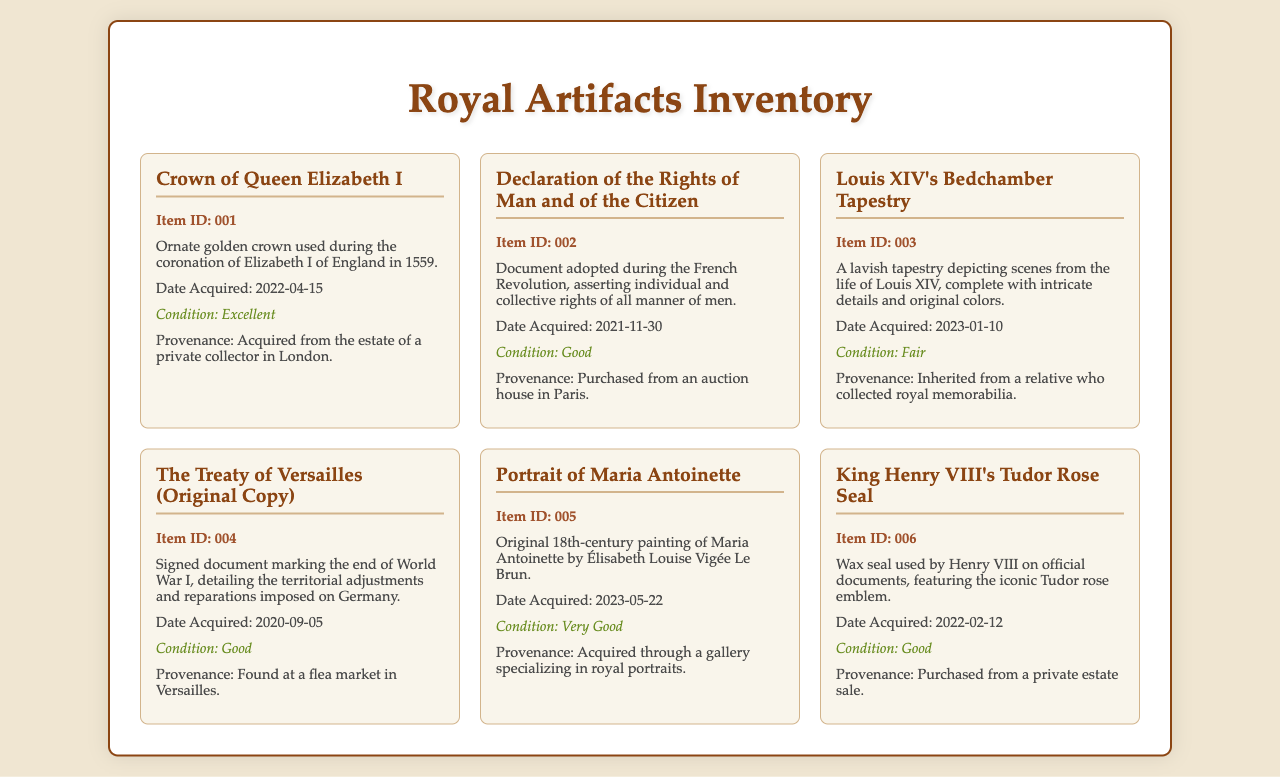What is the item ID of the Crown of Queen Elizabeth I? The item ID is specified next to the artifact title in the document.
Answer: 001 What is the condition of Louis XIV's Bedchamber Tapestry? The condition is mentioned below the description of the artifact.
Answer: Fair Who is the artist of the Portrait of Maria Antoinette? The artist's name is included in the description of the painting.
Answer: Élisabeth Louise Vigée Le Brun When was the Declaration of the Rights of Man and of the Citizen acquired? The acquisition date is listed under each artifact's description.
Answer: 2021-11-30 From where was the Crown of Queen Elizabeth I acquired? The provenance details are provided under the condition of each artifact.
Answer: From the estate of a private collector in London How many artifacts are listed in the inventory? The total number of artifacts can be counted by listing each item in the document.
Answer: 6 What type of document is the Treaty of Versailles? The document type is clear from its title and description.
Answer: Signed document What is the acquisition date of the King's Henry VIII Tudor Rose Seal? The acquisition date is listed alongside each artifact's description.
Answer: 2022-02-12 What is the provenance of the Portrait of Maria Antoinette? The provenance is detailed in the description of the artifact.
Answer: Acquired through a gallery specializing in royal portraits 